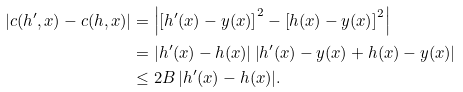Convert formula to latex. <formula><loc_0><loc_0><loc_500><loc_500>| c ( h ^ { \prime } , x ) - c ( h , x ) | & = \left | \left [ h ^ { \prime } ( x ) - y ( x ) \right ] ^ { 2 } - \left [ h ( x ) - y ( x ) \right ] ^ { 2 } \right | \\ & = \left | h ^ { \prime } ( x ) - h ( x ) \right | \left | h ^ { \prime } ( x ) - y ( x ) + h ( x ) - y ( x ) \right | \\ & \leq 2 B \, | h ^ { \prime } ( x ) - h ( x ) | .</formula> 